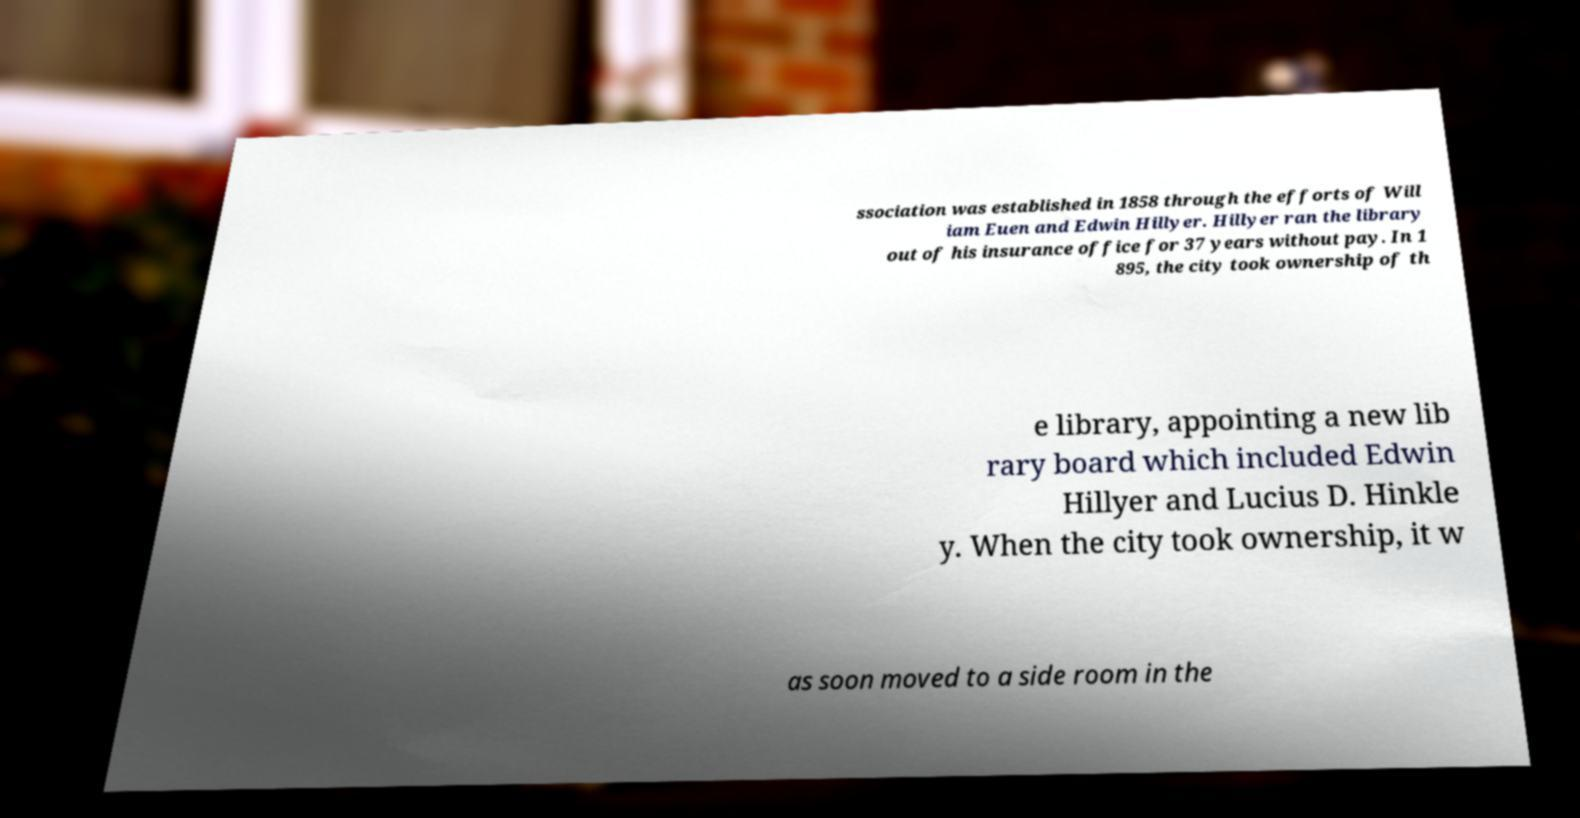Could you extract and type out the text from this image? ssociation was established in 1858 through the efforts of Will iam Euen and Edwin Hillyer. Hillyer ran the library out of his insurance office for 37 years without pay. In 1 895, the city took ownership of th e library, appointing a new lib rary board which included Edwin Hillyer and Lucius D. Hinkle y. When the city took ownership, it w as soon moved to a side room in the 